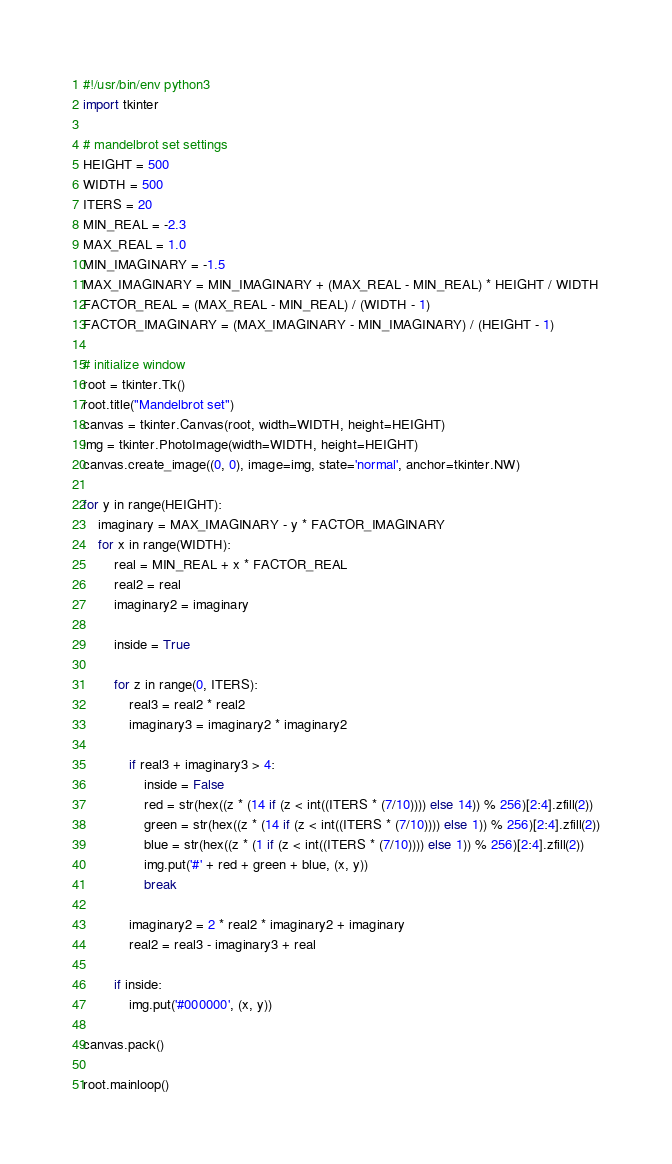Convert code to text. <code><loc_0><loc_0><loc_500><loc_500><_Python_>#!/usr/bin/env python3
import tkinter

# mandelbrot set settings
HEIGHT = 500
WIDTH = 500
ITERS = 20
MIN_REAL = -2.3
MAX_REAL = 1.0
MIN_IMAGINARY = -1.5
MAX_IMAGINARY = MIN_IMAGINARY + (MAX_REAL - MIN_REAL) * HEIGHT / WIDTH
FACTOR_REAL = (MAX_REAL - MIN_REAL) / (WIDTH - 1)
FACTOR_IMAGINARY = (MAX_IMAGINARY - MIN_IMAGINARY) / (HEIGHT - 1)

# initialize window
root = tkinter.Tk()
root.title("Mandelbrot set")
canvas = tkinter.Canvas(root, width=WIDTH, height=HEIGHT)
img = tkinter.PhotoImage(width=WIDTH, height=HEIGHT)
canvas.create_image((0, 0), image=img, state='normal', anchor=tkinter.NW)

for y in range(HEIGHT):
    imaginary = MAX_IMAGINARY - y * FACTOR_IMAGINARY
    for x in range(WIDTH):
        real = MIN_REAL + x * FACTOR_REAL
        real2 = real
        imaginary2 = imaginary

        inside = True

        for z in range(0, ITERS):
            real3 = real2 * real2
            imaginary3 = imaginary2 * imaginary2

            if real3 + imaginary3 > 4:
                inside = False
                red = str(hex((z * (14 if (z < int((ITERS * (7/10)))) else 14)) % 256)[2:4].zfill(2))
                green = str(hex((z * (14 if (z < int((ITERS * (7/10)))) else 1)) % 256)[2:4].zfill(2))
                blue = str(hex((z * (1 if (z < int((ITERS * (7/10)))) else 1)) % 256)[2:4].zfill(2))
                img.put('#' + red + green + blue, (x, y))
                break

            imaginary2 = 2 * real2 * imaginary2 + imaginary
            real2 = real3 - imaginary3 + real

        if inside:
            img.put('#000000', (x, y))

canvas.pack()

root.mainloop()
</code> 